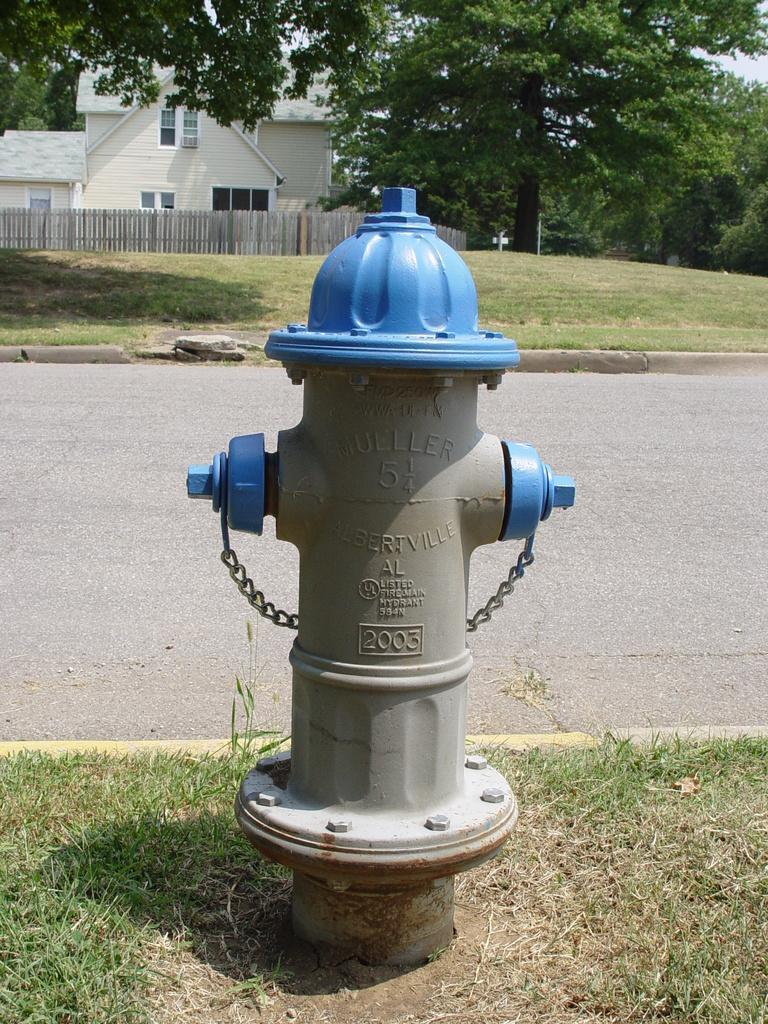In one or two sentences, can you explain what this image depicts? In this image there is a water hydrant on the ground. There is grass on the ground. Behind it there is a road. Beside the road there's grass on the ground. In the background there are trees and a house. There is a wooden fencing around the house. At the top there is the sky. 